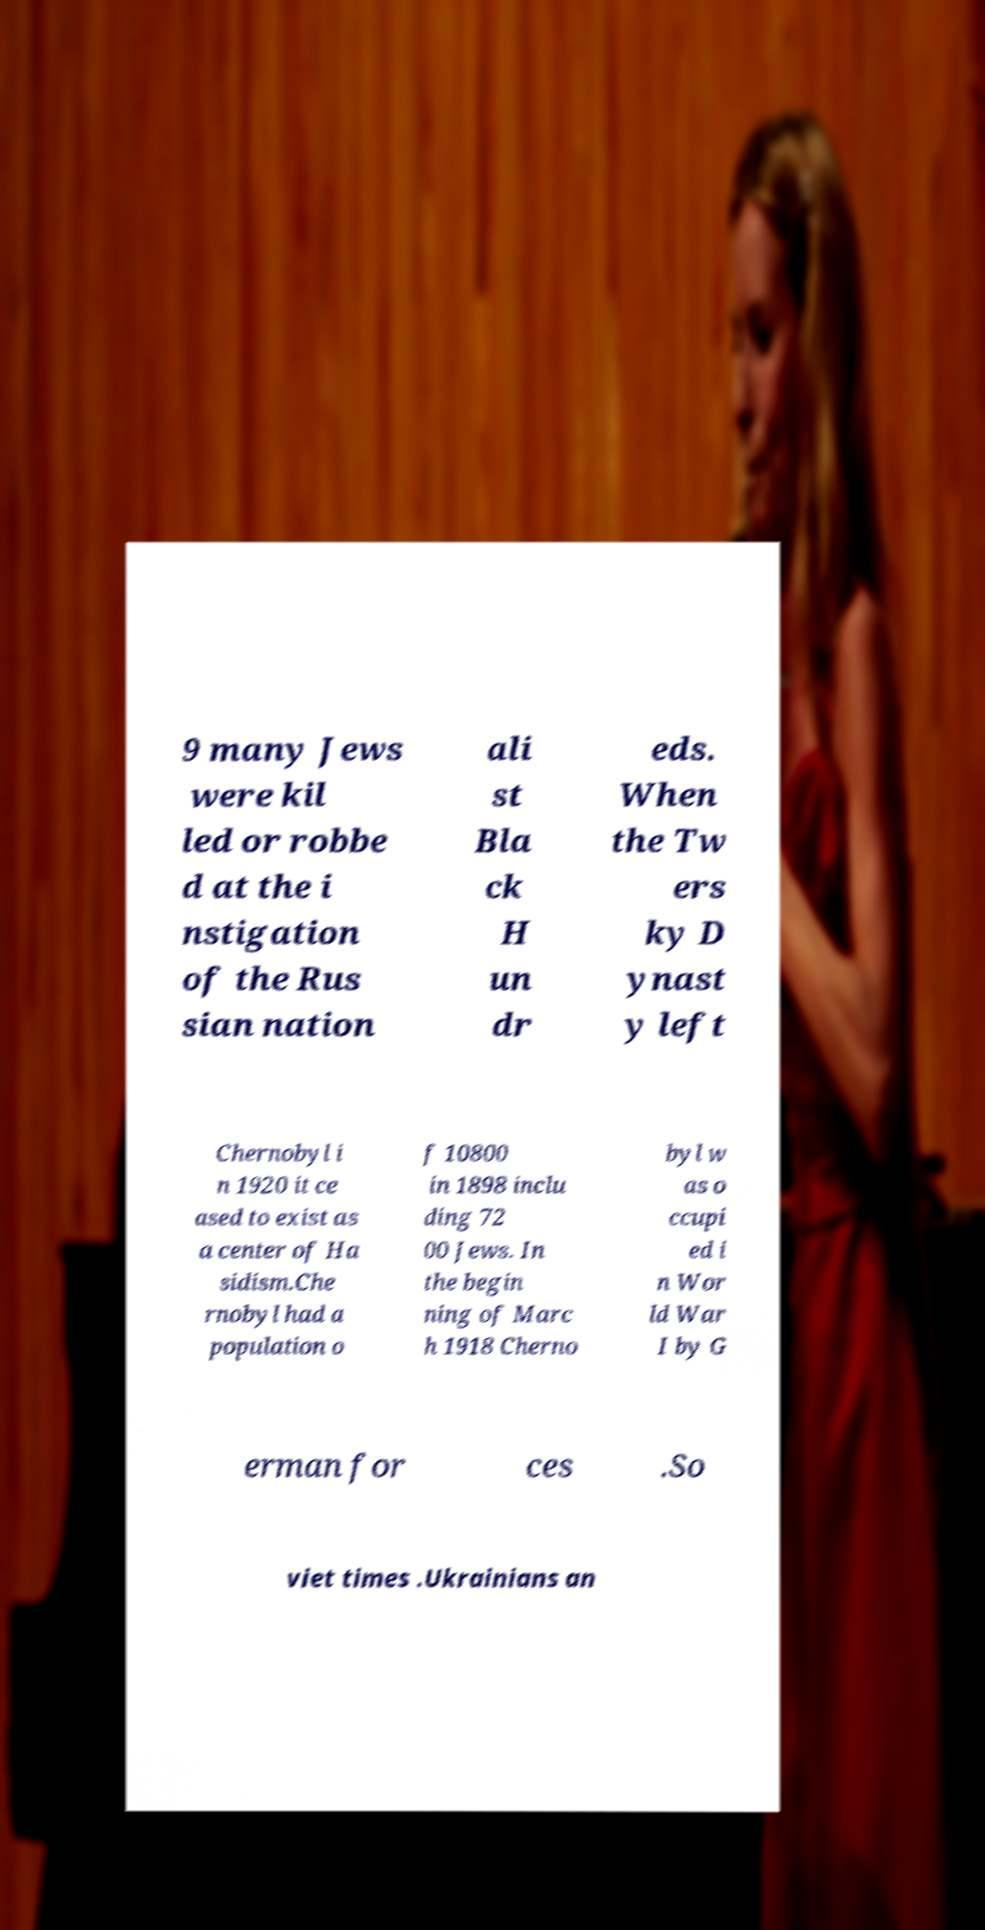I need the written content from this picture converted into text. Can you do that? 9 many Jews were kil led or robbe d at the i nstigation of the Rus sian nation ali st Bla ck H un dr eds. When the Tw ers ky D ynast y left Chernobyl i n 1920 it ce ased to exist as a center of Ha sidism.Che rnobyl had a population o f 10800 in 1898 inclu ding 72 00 Jews. In the begin ning of Marc h 1918 Cherno byl w as o ccupi ed i n Wor ld War I by G erman for ces .So viet times .Ukrainians an 